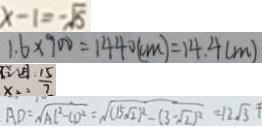<formula> <loc_0><loc_0><loc_500><loc_500>x - 1 = - \sqrt { 5 } 
 1 . 6 \times 9 0 0 = 1 4 4 0 ( c m ) = 1 4 . 4 ( m ) 
 x _ { 2 } = \frac { 1 5 } { 7 } 
 A D = \sqrt { A C ^ { 2 } - C D ^ { 2 } } = \sqrt { ( 1 5 \sqrt { 2 } ^ { 2 } ) - ( 3 - \sqrt { 2 } ) ^ { 2 } } = 1 2 \sqrt { 3 }</formula> 